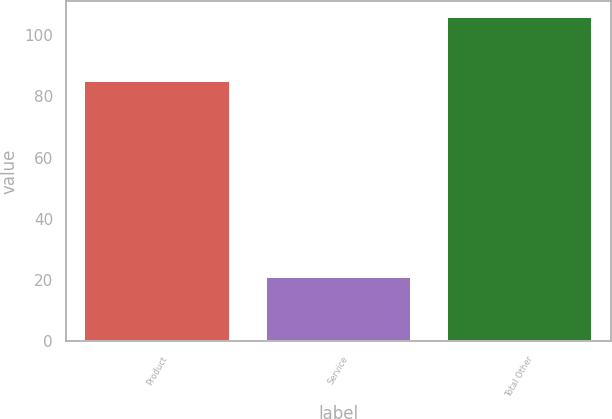Convert chart to OTSL. <chart><loc_0><loc_0><loc_500><loc_500><bar_chart><fcel>Product<fcel>Service<fcel>Total Other<nl><fcel>85<fcel>21<fcel>106<nl></chart> 